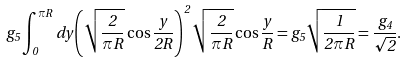Convert formula to latex. <formula><loc_0><loc_0><loc_500><loc_500>g _ { 5 } \int _ { 0 } ^ { \pi R } d y \left ( \sqrt { \frac { 2 } { \pi R } } \cos \frac { y } { 2 R } \right ) ^ { 2 } \sqrt { \frac { 2 } { \pi R } } \cos \frac { y } { R } = g _ { 5 } \sqrt { \frac { 1 } { 2 \pi R } } = \frac { g _ { 4 } } { \sqrt { 2 } } .</formula> 